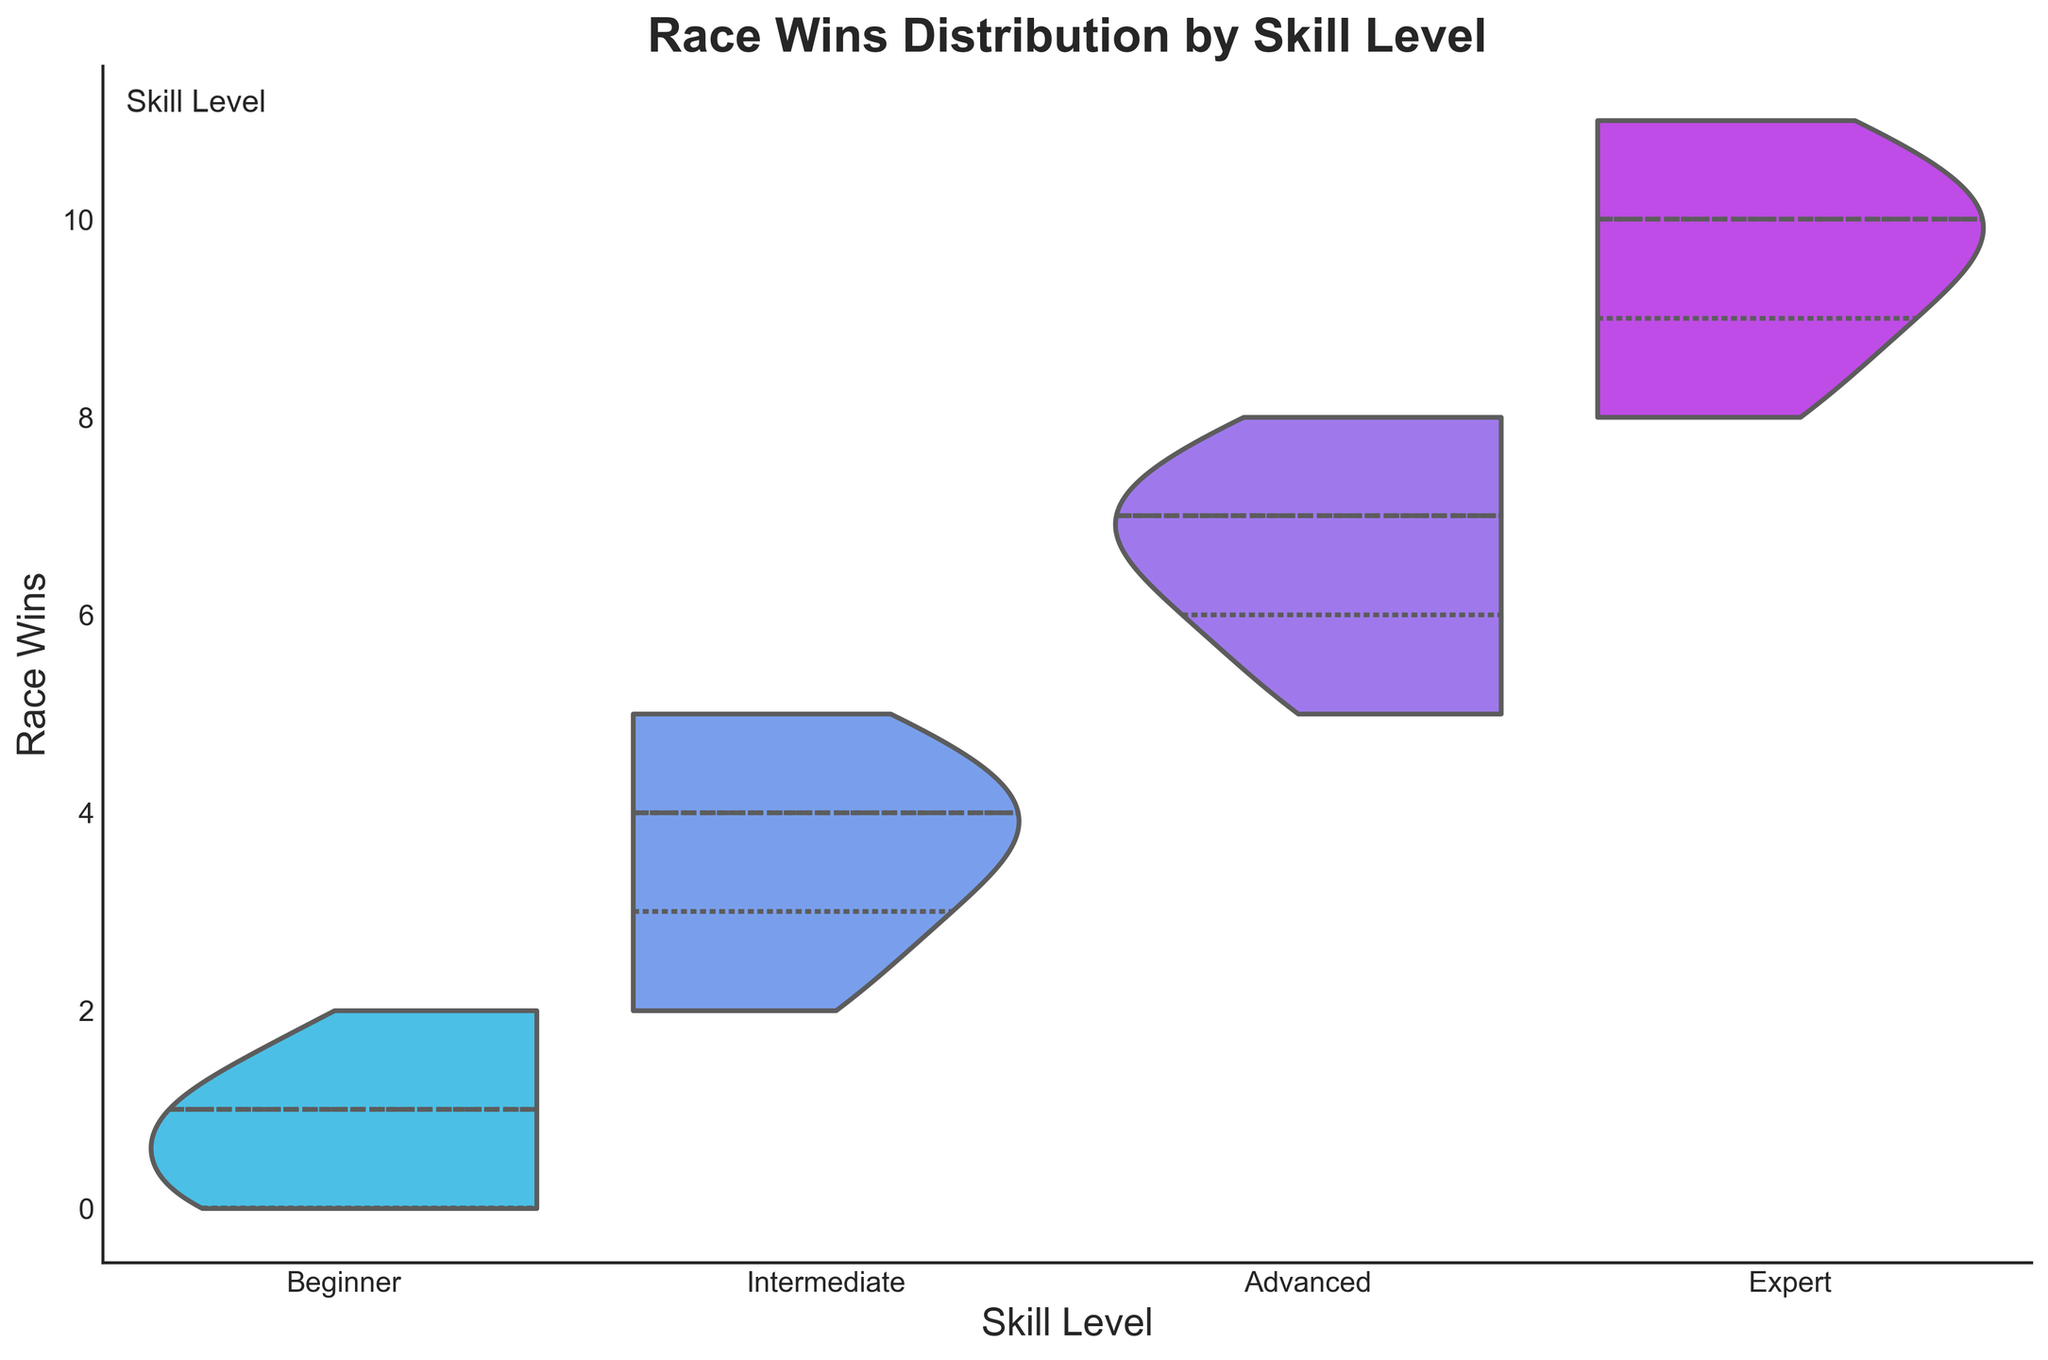what is the title of the plot? The plot has a clear and prominent title at the top center.
Answer: Race Wins Distribution by Skill Level Which skill level appears to have the highest range of race wins? By observing the spread of the violin plots, the "Expert" skill level shows the widest range of race wins.
Answer: Expert How do the median race wins compare between the 'Intermediate' and 'Advanced' skill levels? Looking at the inner quartiles of the violin plots, the dotted lines indicate that the median of 'Advanced' is higher than that of 'Intermediate'.
Answer: Advanced is higher What is the maximum number of race wins observed for the 'Beginner' skill level? By checking the uppermost point of the violin plot for 'Beginner', you see that the maximum race wins are 2.
Answer: 2 Considering the spread, which skill level exhibits the least variability in race wins? The 'Expert' skill level has the shortest and narrowest spread, hence the least variability.
Answer: Expert Do we see a visible trend in race wins with increasing skill levels? As the skill level progresses from 'Beginner' to 'Expert', the median and upper range of race wins increase, indicating a positive trend.
Answer: Yes Between 'Beginner' and 'Intermediate', which skill level has a higher lower quartile of race wins? Observing the lower quartile lines within the violin plots, 'Intermediate' shows a higher lower quartile than 'Beginner'.
Answer: Intermediate How does the interquartile range of race wins for 'Advanced' compare to 'Expert'? The interquartile range, indicated by the box inside the violins, appears narrower for 'Expert' compared to 'Advanced'.
Answer: Expert is narrower Is there a clear separation in race wins between 'Advanced' and 'Expert' skill levels? Although 'Expert' generally has higher race wins, there is some overlapping, but they still show clear separation mostly.
Answer: Yes, but some overlap Which skill level seems most competitive, based on race wins spread? 'Advanced' has a wide spread with race wins ranging from 5 to 8, indicating a competitive distribution.
Answer: Advanced 